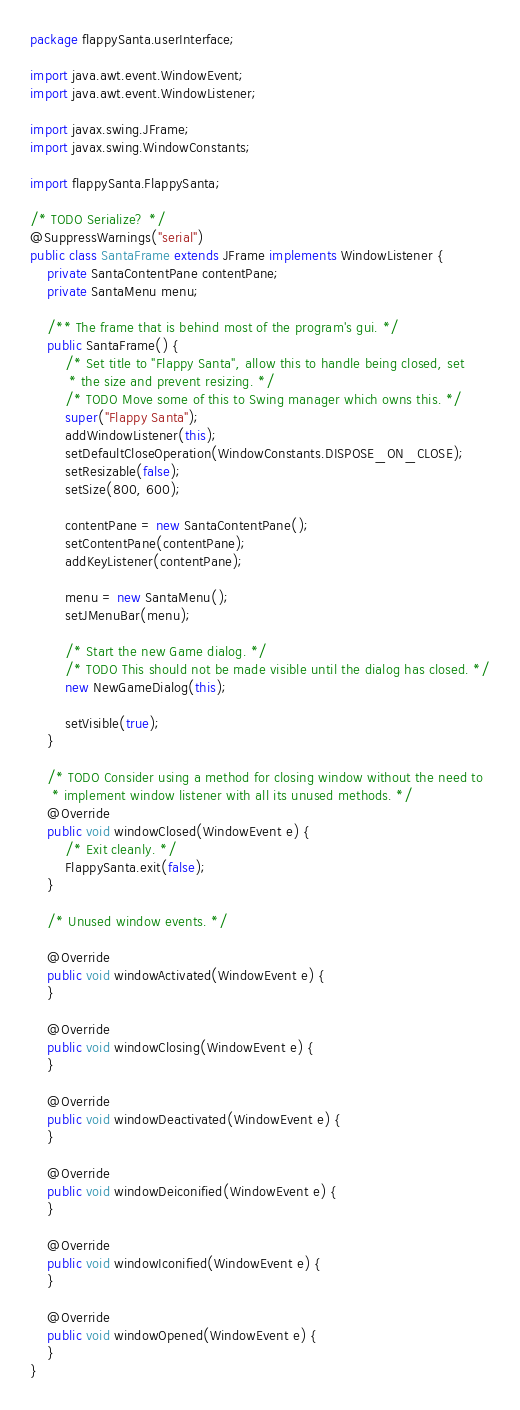Convert code to text. <code><loc_0><loc_0><loc_500><loc_500><_Java_>package flappySanta.userInterface;

import java.awt.event.WindowEvent;
import java.awt.event.WindowListener;

import javax.swing.JFrame;
import javax.swing.WindowConstants;

import flappySanta.FlappySanta;

/* TODO Serialize? */
@SuppressWarnings("serial")
public class SantaFrame extends JFrame implements WindowListener {
	private SantaContentPane contentPane;
	private SantaMenu menu;

	/** The frame that is behind most of the program's gui. */
	public SantaFrame() {
		/* Set title to "Flappy Santa", allow this to handle being closed, set
		 * the size and prevent resizing. */
		/* TODO Move some of this to Swing manager which owns this. */
		super("Flappy Santa");
		addWindowListener(this);
		setDefaultCloseOperation(WindowConstants.DISPOSE_ON_CLOSE);
		setResizable(false);
		setSize(800, 600);

		contentPane = new SantaContentPane();
		setContentPane(contentPane);
		addKeyListener(contentPane);

		menu = new SantaMenu();
		setJMenuBar(menu);

		/* Start the new Game dialog. */
		/* TODO This should not be made visible until the dialog has closed. */
		new NewGameDialog(this);

		setVisible(true);
	}

	/* TODO Consider using a method for closing window without the need to
	 * implement window listener with all its unused methods. */
	@Override
	public void windowClosed(WindowEvent e) {
		/* Exit cleanly. */
		FlappySanta.exit(false);
	}

	/* Unused window events. */

	@Override
	public void windowActivated(WindowEvent e) {
	}

	@Override
	public void windowClosing(WindowEvent e) {
	}

	@Override
	public void windowDeactivated(WindowEvent e) {
	}

	@Override
	public void windowDeiconified(WindowEvent e) {
	}

	@Override
	public void windowIconified(WindowEvent e) {
	}

	@Override
	public void windowOpened(WindowEvent e) {
	}
}
</code> 